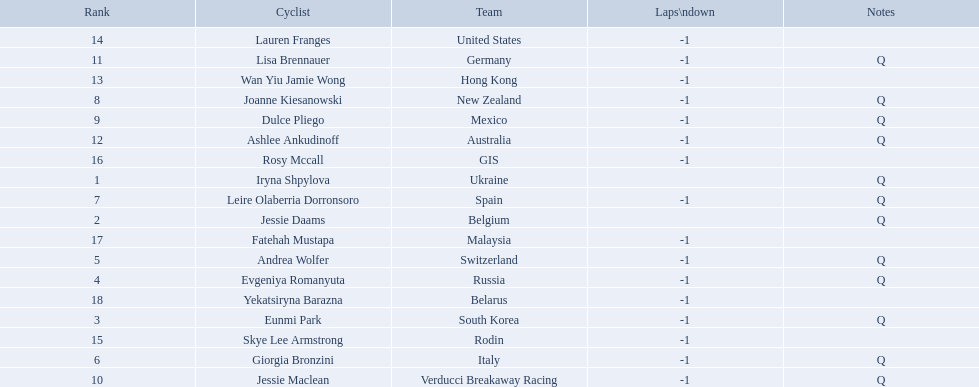Who competed in the race? Iryna Shpylova, Jessie Daams, Eunmi Park, Evgeniya Romanyuta, Andrea Wolfer, Giorgia Bronzini, Leire Olaberria Dorronsoro, Joanne Kiesanowski, Dulce Pliego, Jessie Maclean, Lisa Brennauer, Ashlee Ankudinoff, Wan Yiu Jamie Wong, Lauren Franges, Skye Lee Armstrong, Rosy Mccall, Fatehah Mustapa, Yekatsiryna Barazna. Who ranked highest in the race? Iryna Shpylova. 